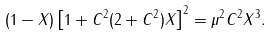<formula> <loc_0><loc_0><loc_500><loc_500>( 1 - X ) \left [ 1 + C ^ { 2 } ( 2 + C ^ { 2 } ) X \right ] ^ { 2 } = \mu ^ { 2 } C ^ { 2 } X ^ { 3 } .</formula> 